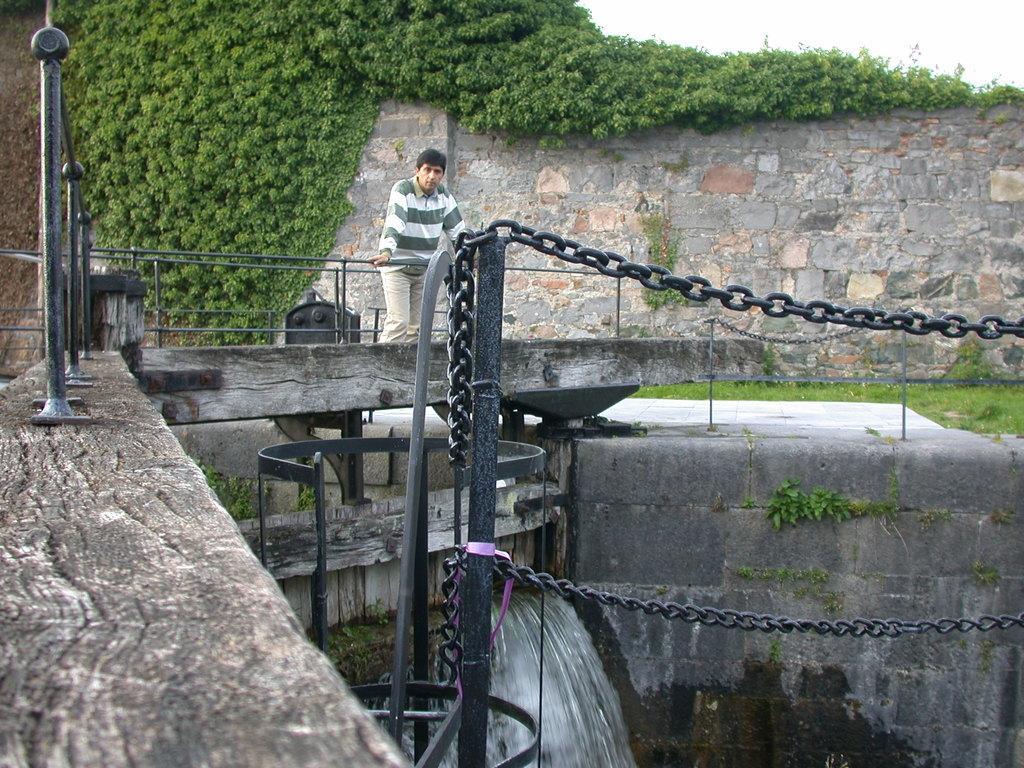Describe this image in one or two sentences. Bottom of the image there is fencing. Behind the fencing a person is standing and there is water. Top of the image there are some trees and wall. Top right side of the image there is sky. 